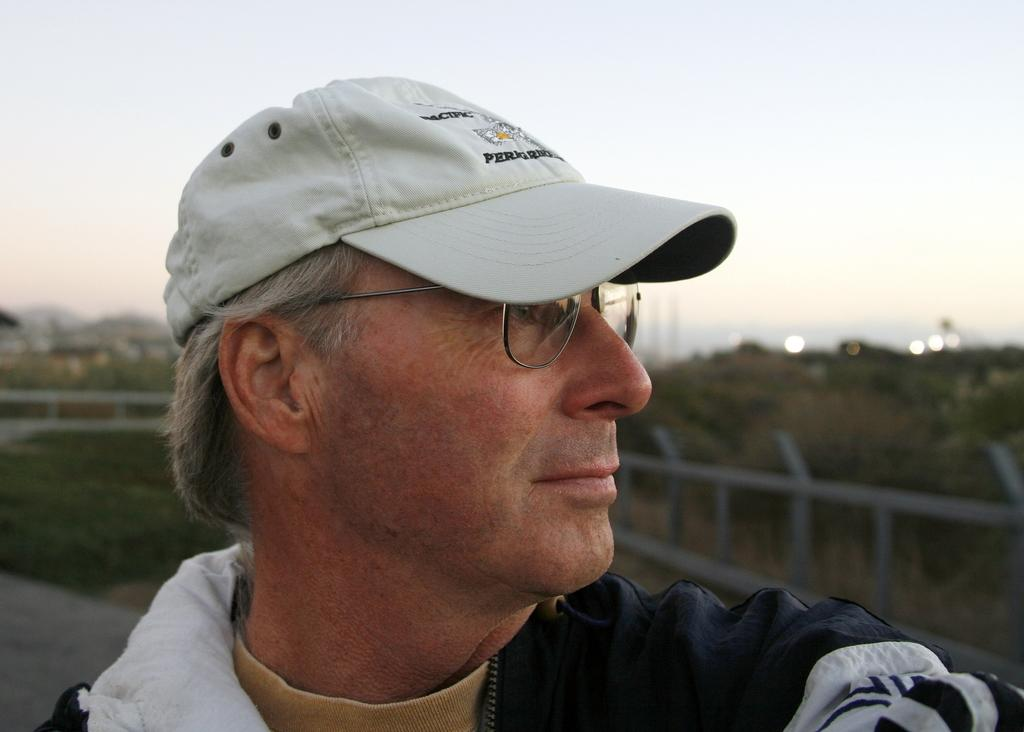What is the age of the person in the image? There is an old man in the image. What is the old man wearing on his upper body? The old man is wearing a black jacket. What is the old man wearing on his head? The old man is wearing a white cap. What is the old man's posture in the image? The old man is standing. What is located behind the old man? There is a fence behind the old man. What can be seen in the distance in the image? There is a hill in the background of the image, and the sky is visible above the hill. What is the old man's mindset in the image? The image does not provide information about the old man's mindset or thoughts. Can you see a kitten playing on the hill in the background of the image? There is no kitten present in the image; only the old man, fence, and hill are visible. 